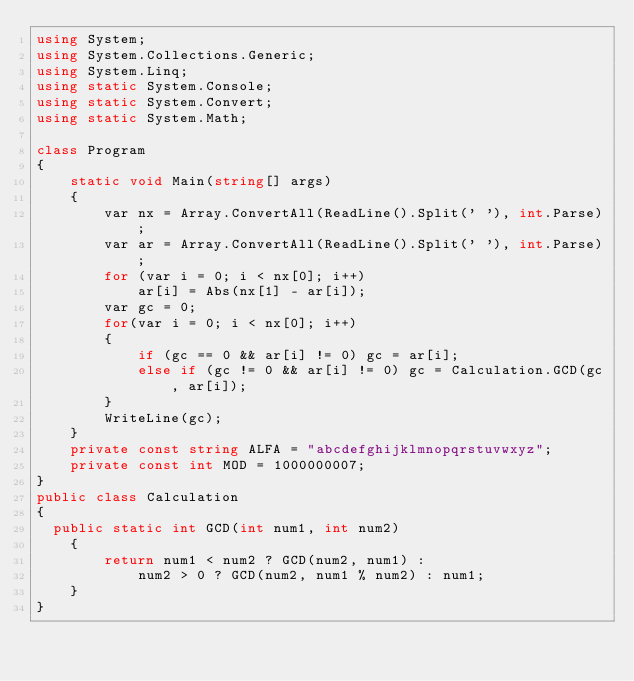Convert code to text. <code><loc_0><loc_0><loc_500><loc_500><_C#_>using System;
using System.Collections.Generic;
using System.Linq;
using static System.Console;
using static System.Convert;
using static System.Math;

class Program
{
    static void Main(string[] args)
    {
        var nx = Array.ConvertAll(ReadLine().Split(' '), int.Parse);
        var ar = Array.ConvertAll(ReadLine().Split(' '), int.Parse);
        for (var i = 0; i < nx[0]; i++)
            ar[i] = Abs(nx[1] - ar[i]);
        var gc = 0;
        for(var i = 0; i < nx[0]; i++)
        {
            if (gc == 0 && ar[i] != 0) gc = ar[i];
            else if (gc != 0 && ar[i] != 0) gc = Calculation.GCD(gc, ar[i]);
        }
        WriteLine(gc);
    }
    private const string ALFA = "abcdefghijklmnopqrstuvwxyz";
    private const int MOD = 1000000007;
}
public class Calculation
{
  public static int GCD(int num1, int num2)
    {
        return num1 < num2 ? GCD(num2, num1) :
            num2 > 0 ? GCD(num2, num1 % num2) : num1;
    }
}</code> 